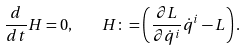<formula> <loc_0><loc_0><loc_500><loc_500>\frac { d } { d t } H = 0 , \quad H \colon = \left ( \frac { \partial L } { \partial \dot { q } ^ { i } } \dot { q } ^ { i } - L \right ) .</formula> 